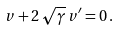<formula> <loc_0><loc_0><loc_500><loc_500>v + 2 \, \sqrt { \gamma } \, v ^ { \prime } = 0 \, .</formula> 